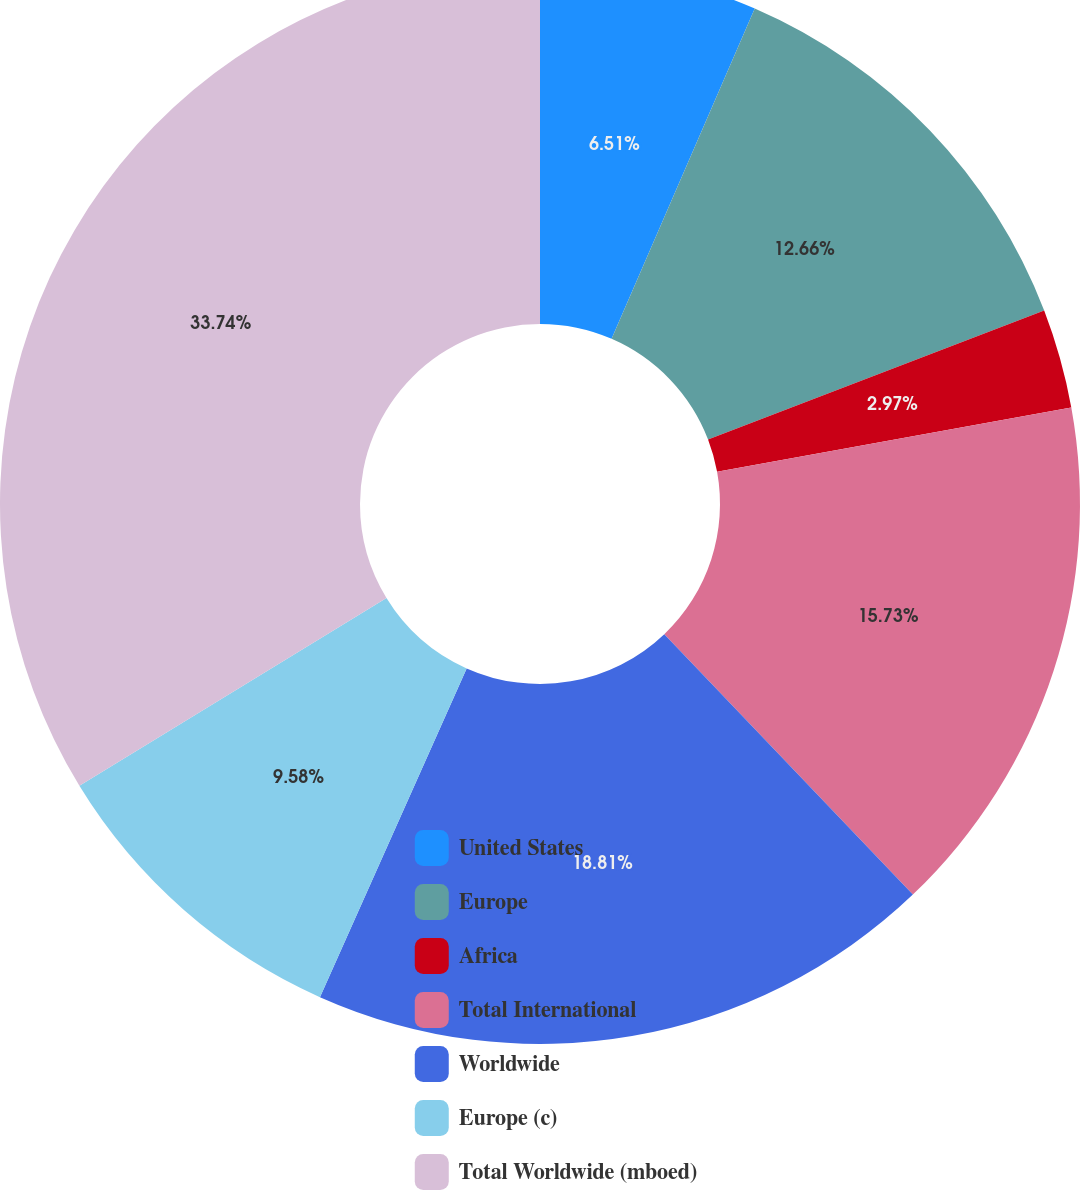<chart> <loc_0><loc_0><loc_500><loc_500><pie_chart><fcel>United States<fcel>Europe<fcel>Africa<fcel>Total International<fcel>Worldwide<fcel>Europe (c)<fcel>Total Worldwide (mboed)<nl><fcel>6.51%<fcel>12.66%<fcel>2.97%<fcel>15.73%<fcel>18.81%<fcel>9.58%<fcel>33.74%<nl></chart> 